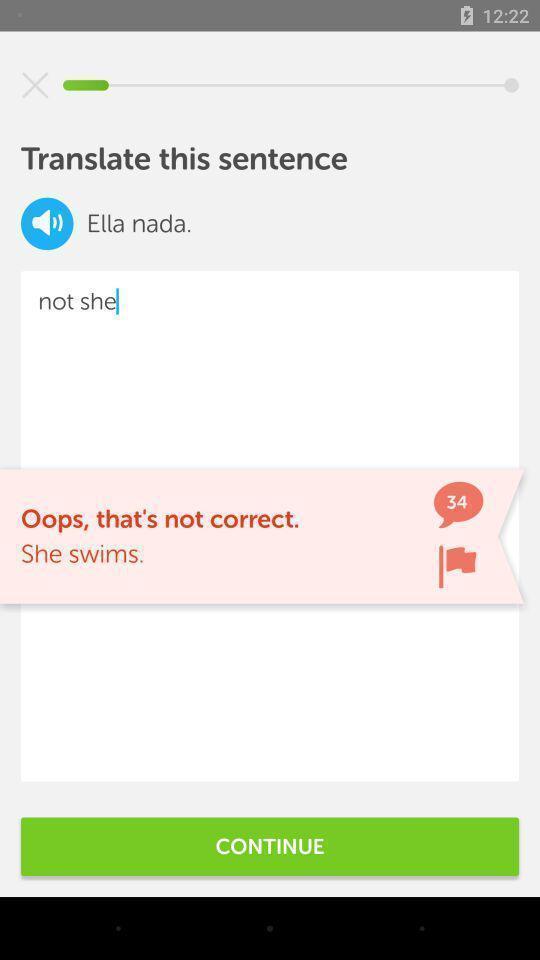Describe this image in words. Translation page displayed in a language learning app. 